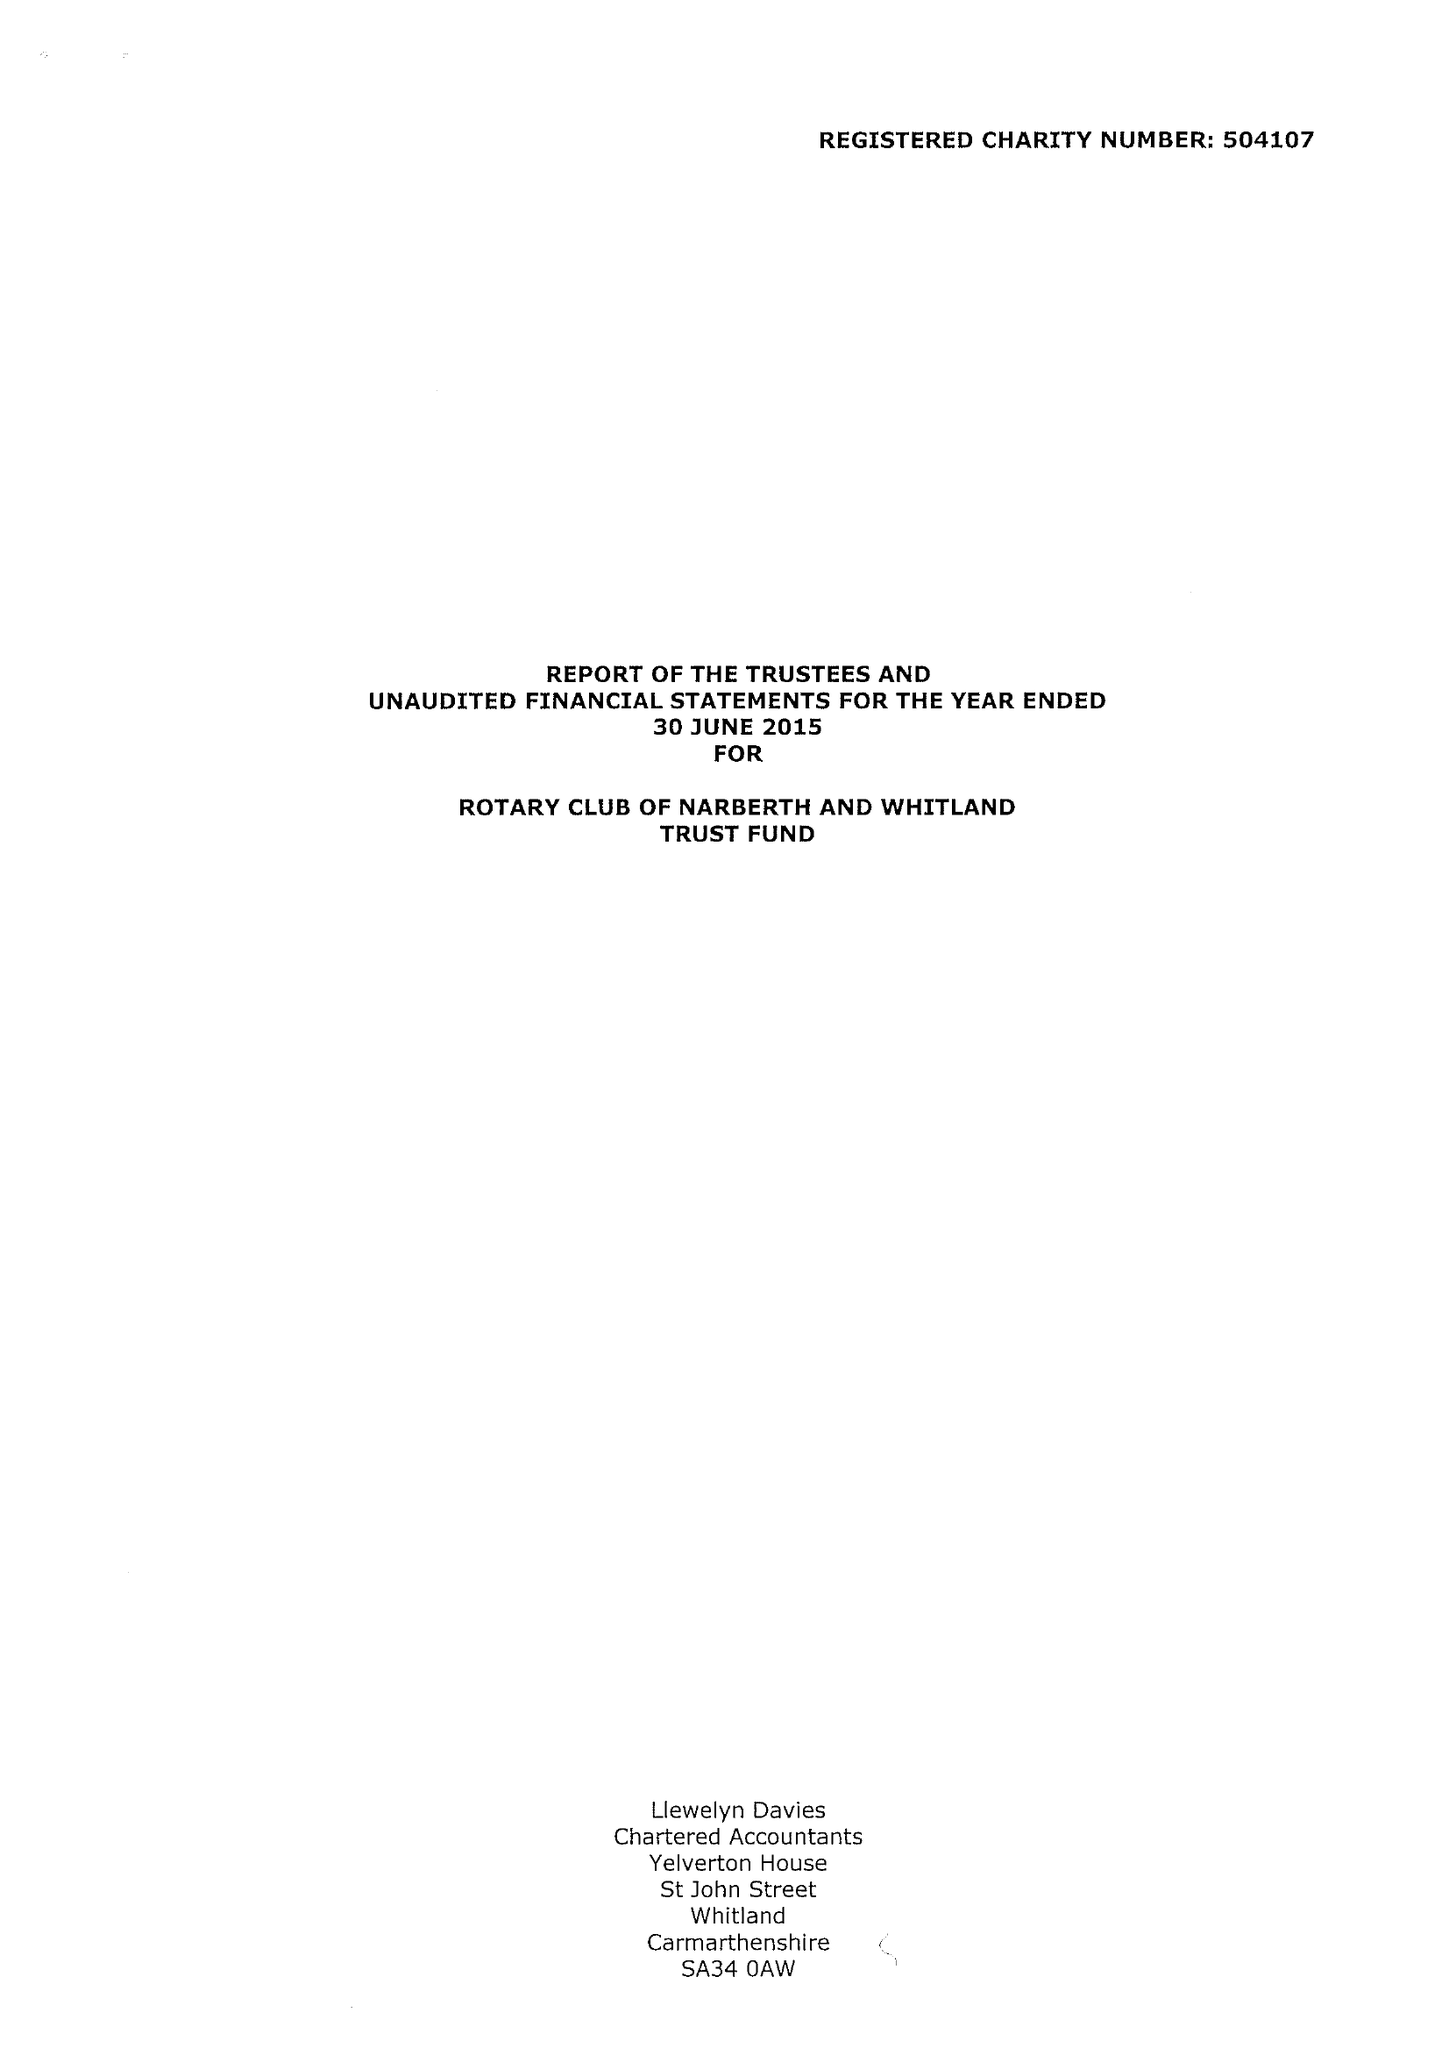What is the value for the spending_annually_in_british_pounds?
Answer the question using a single word or phrase. 46033.00 